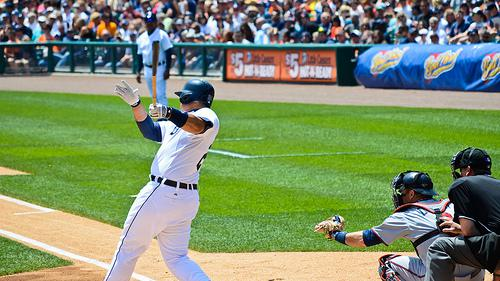Question: what sport is shown?
Choices:
A. Football.
B. Hockey.
C. Soccer.
D. Baseball.
Answer with the letter. Answer: D Question: where was this shot?
Choices:
A. At a stadium.
B. In the building.
C. Ball park.
D. Outside by the tree.
Answer with the letter. Answer: C Question: how many players are shown?
Choices:
A. 2.
B. 4.
C. 3.
D. 20.
Answer with the letter. Answer: C Question: what color does the umpire wear?
Choices:
A. Black.
B. White.
C. Red.
D. Green.
Answer with the letter. Answer: A 